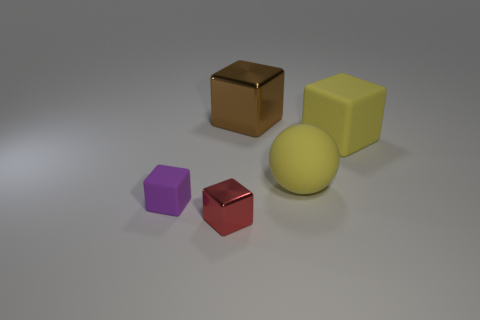Can you describe the shapes and colors of the objects in the image? Certainly! The image features five objects with a variety of shapes and colors. Starting from the left, there is a purple cube, a brown cube with a slightly reflective surface suggesting it could be made of rubber, a yellow cube with a matte finish, a small red cube that has a shiny surface, and a big yellow sphere in the background. These objects provide a contrast in both color and shape, making the image visually interesting. 